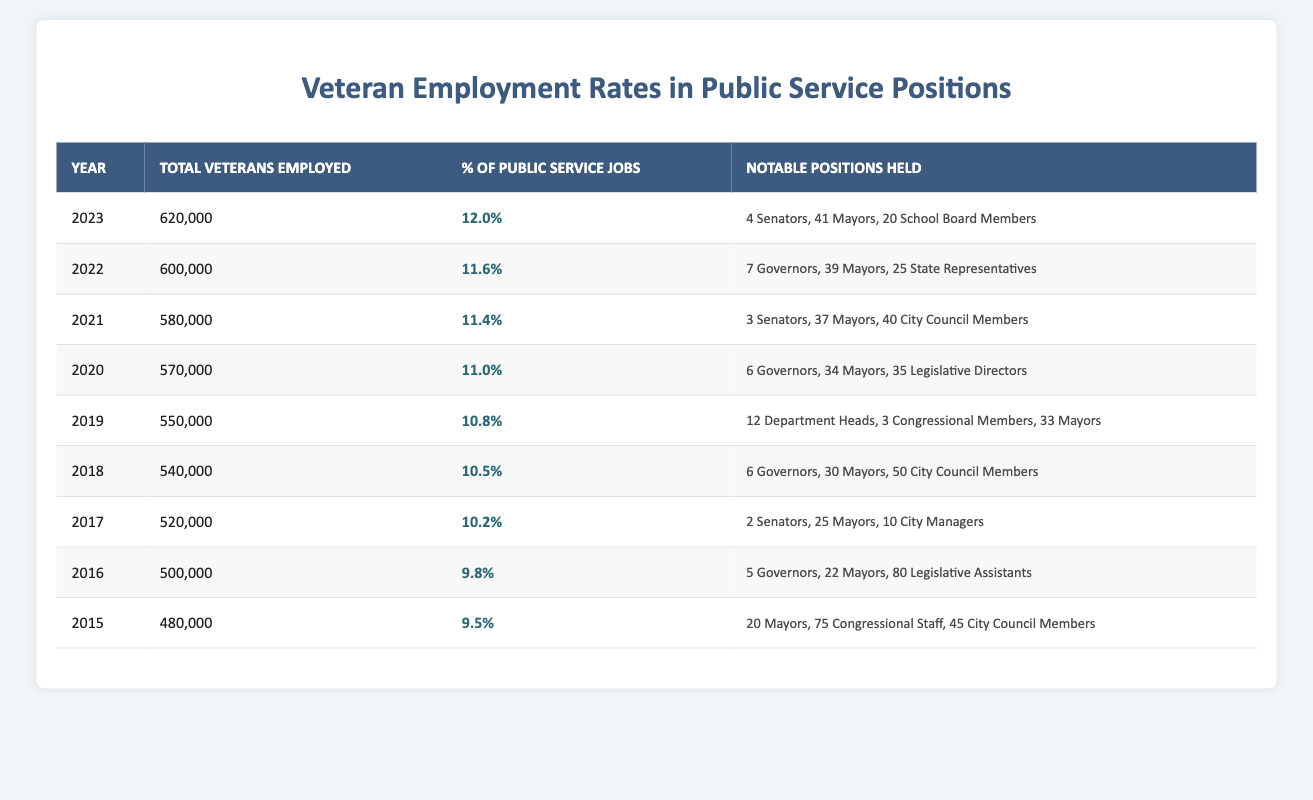What was the total number of veterans employed in public service in 2022? In the table, the "Total Veterans Employed" for the year 2022 is clearly listed as 600,000.
Answer: 600,000 What percentage of public service jobs were held by veterans in 2019? The table states that in 2019, the percent of public service jobs held by veterans is 10.8%.
Answer: 10.8% Which year saw the highest number of veterans employed in public service? By comparing the "Total Veterans Employed" for each year, 2023 has the highest number at 620,000.
Answer: 2023 How many mayors held positions in public service in 2021? The table indicates that 37 mayors were veterans employed in public service positions in 2021.
Answer: 37 What is the difference in the total number of veterans employed in public service between 2015 and 2023? The total veterans employed in 2023 is 620,000 and in 2015 it is 480,000. The difference is 620,000 - 480,000 = 140,000.
Answer: 140,000 Did the percentage of veterans in public service jobs increase or decrease from 2018 to 2019? In 2018 the percentage is 10.5%, and in 2019 it is 10.8%. Since 10.8% > 10.5%, the percentage increased.
Answer: Increase What was the total number of notable positions held by veterans in 2020, including governors, mayors, and legislative directors? In 2020, veterans held positions as follows: 6 governors, 34 mayors, and 35 legislative directors. Totaling these gives 6 + 34 + 35 = 75.
Answer: 75 How many total veterans were employed in public service over the years from 2015 to 2023? Summing the total veterans from each year: 480,000 (2015) + 500,000 (2016) + 520,000 (2017) + 540,000 (2018) + 550,000 (2019) + 570,000 (2020) + 580,000 (2021) + 600,000 (2022) + 620,000 (2023) gives 4,610,000.
Answer: 4,610,000 Which year had the lowest percentage of public service jobs held by veterans? The table shows that 2015 had the lowest percentage at 9.5%.
Answer: 2015 If we average the number of veterans employed in public service from 2015 to 2021, what do we get? The total veterans employed from 2015 to 2021 is 480,000 + 500,000 + 520,000 + 540,000 + 570,000 + 580,000 = 3,190,000. Dividing by 7 gives an average of about 456,428.57.
Answer: 456,429 How many senators were veterans in 2023 compared to the previous year? In 2023, there were 4 senators, while in 2022 there were 7 senators. So there were 3 fewer senators in 2023.
Answer: 3 fewer 